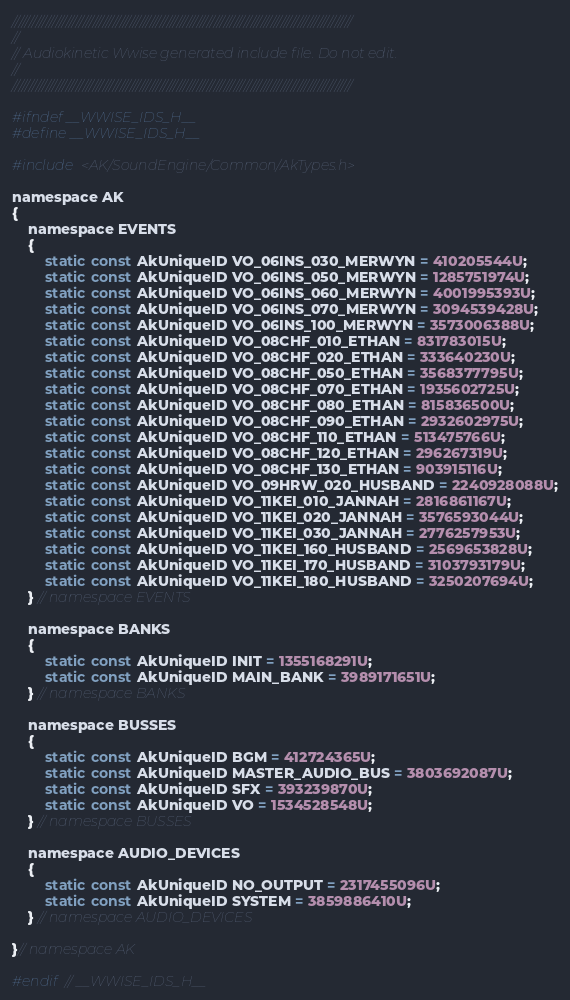<code> <loc_0><loc_0><loc_500><loc_500><_C_>/////////////////////////////////////////////////////////////////////////////////////////////////////
//
// Audiokinetic Wwise generated include file. Do not edit.
//
/////////////////////////////////////////////////////////////////////////////////////////////////////

#ifndef __WWISE_IDS_H__
#define __WWISE_IDS_H__

#include <AK/SoundEngine/Common/AkTypes.h>

namespace AK
{
    namespace EVENTS
    {
        static const AkUniqueID VO_06INS_030_MERWYN = 410205544U;
        static const AkUniqueID VO_06INS_050_MERWYN = 1285751974U;
        static const AkUniqueID VO_06INS_060_MERWYN = 4001995393U;
        static const AkUniqueID VO_06INS_070_MERWYN = 3094539428U;
        static const AkUniqueID VO_06INS_100_MERWYN = 3573006388U;
        static const AkUniqueID VO_08CHF_010_ETHAN = 831783015U;
        static const AkUniqueID VO_08CHF_020_ETHAN = 333640230U;
        static const AkUniqueID VO_08CHF_050_ETHAN = 3568377795U;
        static const AkUniqueID VO_08CHF_070_ETHAN = 1935602725U;
        static const AkUniqueID VO_08CHF_080_ETHAN = 815836500U;
        static const AkUniqueID VO_08CHF_090_ETHAN = 2932602975U;
        static const AkUniqueID VO_08CHF_110_ETHAN = 513475766U;
        static const AkUniqueID VO_08CHF_120_ETHAN = 296267319U;
        static const AkUniqueID VO_08CHF_130_ETHAN = 903915116U;
        static const AkUniqueID VO_09HRW_020_HUSBAND = 2240928088U;
        static const AkUniqueID VO_11KEI_010_JANNAH = 2816861167U;
        static const AkUniqueID VO_11KEI_020_JANNAH = 3576593044U;
        static const AkUniqueID VO_11KEI_030_JANNAH = 2776257953U;
        static const AkUniqueID VO_11KEI_160_HUSBAND = 2569653828U;
        static const AkUniqueID VO_11KEI_170_HUSBAND = 3103793179U;
        static const AkUniqueID VO_11KEI_180_HUSBAND = 3250207694U;
    } // namespace EVENTS

    namespace BANKS
    {
        static const AkUniqueID INIT = 1355168291U;
        static const AkUniqueID MAIN_BANK = 3989171651U;
    } // namespace BANKS

    namespace BUSSES
    {
        static const AkUniqueID BGM = 412724365U;
        static const AkUniqueID MASTER_AUDIO_BUS = 3803692087U;
        static const AkUniqueID SFX = 393239870U;
        static const AkUniqueID VO = 1534528548U;
    } // namespace BUSSES

    namespace AUDIO_DEVICES
    {
        static const AkUniqueID NO_OUTPUT = 2317455096U;
        static const AkUniqueID SYSTEM = 3859886410U;
    } // namespace AUDIO_DEVICES

}// namespace AK

#endif // __WWISE_IDS_H__
</code> 